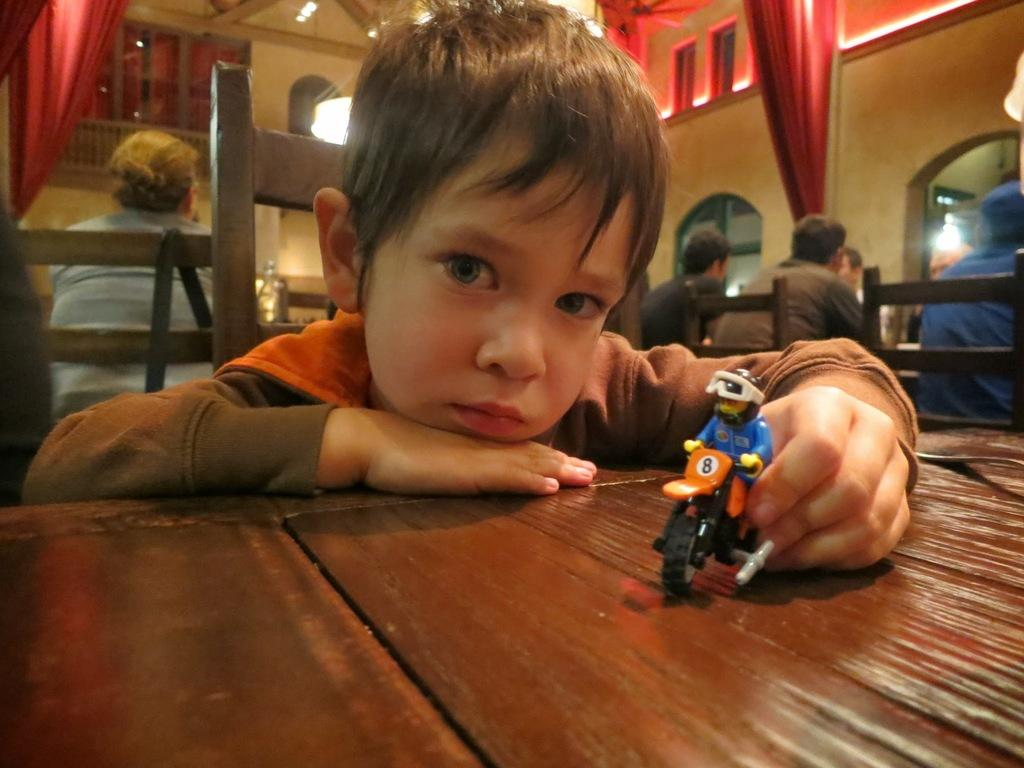Who is the main subject in the image? There is a boy in the image. What is the boy doing in the image? The boy is placing his hands on the table. What is the boy holding in his hand? The boy is holding a toy in his left hand. What is the boy wearing in the image? The boy is wearing a brown color sweater. What type of news can be seen on the sidewalk in the image? There is no news or sidewalk present in the image; it features a boy placing his hands on a table and holding a toy. 